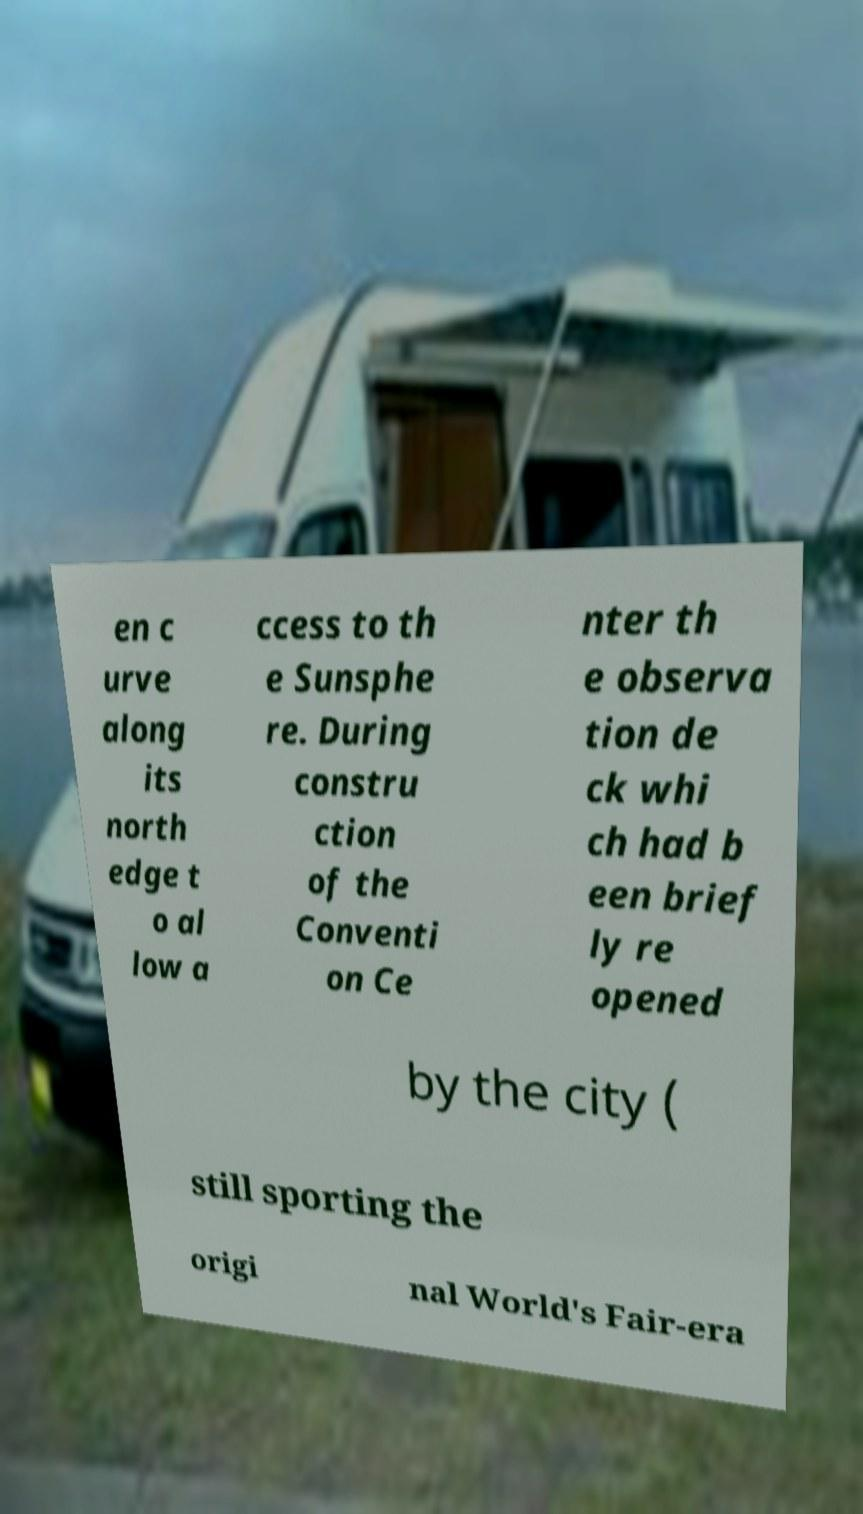For documentation purposes, I need the text within this image transcribed. Could you provide that? en c urve along its north edge t o al low a ccess to th e Sunsphe re. During constru ction of the Conventi on Ce nter th e observa tion de ck whi ch had b een brief ly re opened by the city ( still sporting the origi nal World's Fair-era 